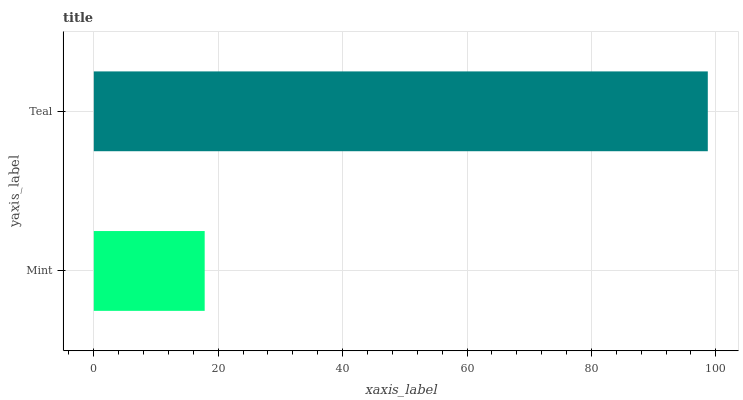Is Mint the minimum?
Answer yes or no. Yes. Is Teal the maximum?
Answer yes or no. Yes. Is Teal the minimum?
Answer yes or no. No. Is Teal greater than Mint?
Answer yes or no. Yes. Is Mint less than Teal?
Answer yes or no. Yes. Is Mint greater than Teal?
Answer yes or no. No. Is Teal less than Mint?
Answer yes or no. No. Is Teal the high median?
Answer yes or no. Yes. Is Mint the low median?
Answer yes or no. Yes. Is Mint the high median?
Answer yes or no. No. Is Teal the low median?
Answer yes or no. No. 